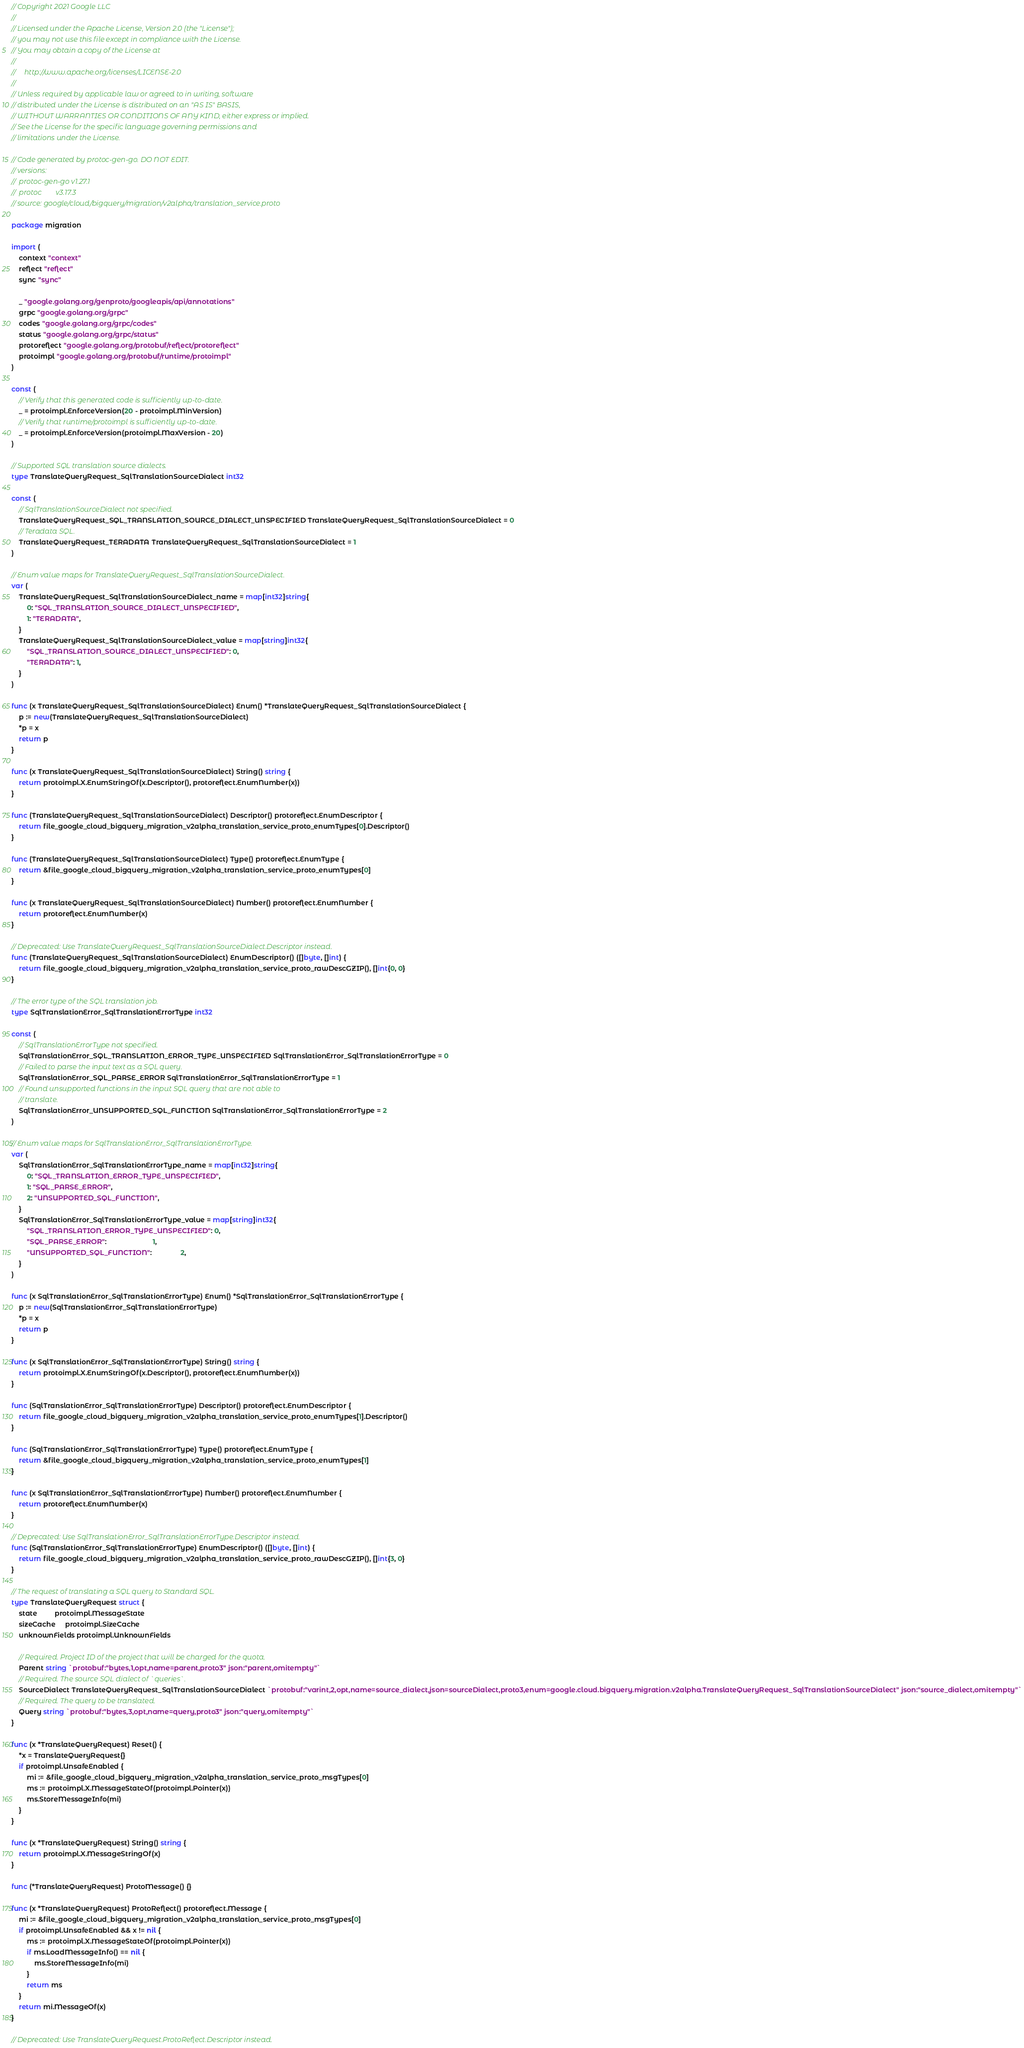Convert code to text. <code><loc_0><loc_0><loc_500><loc_500><_Go_>// Copyright 2021 Google LLC
//
// Licensed under the Apache License, Version 2.0 (the "License");
// you may not use this file except in compliance with the License.
// You may obtain a copy of the License at
//
//     http://www.apache.org/licenses/LICENSE-2.0
//
// Unless required by applicable law or agreed to in writing, software
// distributed under the License is distributed on an "AS IS" BASIS,
// WITHOUT WARRANTIES OR CONDITIONS OF ANY KIND, either express or implied.
// See the License for the specific language governing permissions and
// limitations under the License.

// Code generated by protoc-gen-go. DO NOT EDIT.
// versions:
// 	protoc-gen-go v1.27.1
// 	protoc        v3.17.3
// source: google/cloud/bigquery/migration/v2alpha/translation_service.proto

package migration

import (
	context "context"
	reflect "reflect"
	sync "sync"

	_ "google.golang.org/genproto/googleapis/api/annotations"
	grpc "google.golang.org/grpc"
	codes "google.golang.org/grpc/codes"
	status "google.golang.org/grpc/status"
	protoreflect "google.golang.org/protobuf/reflect/protoreflect"
	protoimpl "google.golang.org/protobuf/runtime/protoimpl"
)

const (
	// Verify that this generated code is sufficiently up-to-date.
	_ = protoimpl.EnforceVersion(20 - protoimpl.MinVersion)
	// Verify that runtime/protoimpl is sufficiently up-to-date.
	_ = protoimpl.EnforceVersion(protoimpl.MaxVersion - 20)
)

// Supported SQL translation source dialects.
type TranslateQueryRequest_SqlTranslationSourceDialect int32

const (
	// SqlTranslationSourceDialect not specified.
	TranslateQueryRequest_SQL_TRANSLATION_SOURCE_DIALECT_UNSPECIFIED TranslateQueryRequest_SqlTranslationSourceDialect = 0
	// Teradata SQL.
	TranslateQueryRequest_TERADATA TranslateQueryRequest_SqlTranslationSourceDialect = 1
)

// Enum value maps for TranslateQueryRequest_SqlTranslationSourceDialect.
var (
	TranslateQueryRequest_SqlTranslationSourceDialect_name = map[int32]string{
		0: "SQL_TRANSLATION_SOURCE_DIALECT_UNSPECIFIED",
		1: "TERADATA",
	}
	TranslateQueryRequest_SqlTranslationSourceDialect_value = map[string]int32{
		"SQL_TRANSLATION_SOURCE_DIALECT_UNSPECIFIED": 0,
		"TERADATA": 1,
	}
)

func (x TranslateQueryRequest_SqlTranslationSourceDialect) Enum() *TranslateQueryRequest_SqlTranslationSourceDialect {
	p := new(TranslateQueryRequest_SqlTranslationSourceDialect)
	*p = x
	return p
}

func (x TranslateQueryRequest_SqlTranslationSourceDialect) String() string {
	return protoimpl.X.EnumStringOf(x.Descriptor(), protoreflect.EnumNumber(x))
}

func (TranslateQueryRequest_SqlTranslationSourceDialect) Descriptor() protoreflect.EnumDescriptor {
	return file_google_cloud_bigquery_migration_v2alpha_translation_service_proto_enumTypes[0].Descriptor()
}

func (TranslateQueryRequest_SqlTranslationSourceDialect) Type() protoreflect.EnumType {
	return &file_google_cloud_bigquery_migration_v2alpha_translation_service_proto_enumTypes[0]
}

func (x TranslateQueryRequest_SqlTranslationSourceDialect) Number() protoreflect.EnumNumber {
	return protoreflect.EnumNumber(x)
}

// Deprecated: Use TranslateQueryRequest_SqlTranslationSourceDialect.Descriptor instead.
func (TranslateQueryRequest_SqlTranslationSourceDialect) EnumDescriptor() ([]byte, []int) {
	return file_google_cloud_bigquery_migration_v2alpha_translation_service_proto_rawDescGZIP(), []int{0, 0}
}

// The error type of the SQL translation job.
type SqlTranslationError_SqlTranslationErrorType int32

const (
	// SqlTranslationErrorType not specified.
	SqlTranslationError_SQL_TRANSLATION_ERROR_TYPE_UNSPECIFIED SqlTranslationError_SqlTranslationErrorType = 0
	// Failed to parse the input text as a SQL query.
	SqlTranslationError_SQL_PARSE_ERROR SqlTranslationError_SqlTranslationErrorType = 1
	// Found unsupported functions in the input SQL query that are not able to
	// translate.
	SqlTranslationError_UNSUPPORTED_SQL_FUNCTION SqlTranslationError_SqlTranslationErrorType = 2
)

// Enum value maps for SqlTranslationError_SqlTranslationErrorType.
var (
	SqlTranslationError_SqlTranslationErrorType_name = map[int32]string{
		0: "SQL_TRANSLATION_ERROR_TYPE_UNSPECIFIED",
		1: "SQL_PARSE_ERROR",
		2: "UNSUPPORTED_SQL_FUNCTION",
	}
	SqlTranslationError_SqlTranslationErrorType_value = map[string]int32{
		"SQL_TRANSLATION_ERROR_TYPE_UNSPECIFIED": 0,
		"SQL_PARSE_ERROR":                        1,
		"UNSUPPORTED_SQL_FUNCTION":               2,
	}
)

func (x SqlTranslationError_SqlTranslationErrorType) Enum() *SqlTranslationError_SqlTranslationErrorType {
	p := new(SqlTranslationError_SqlTranslationErrorType)
	*p = x
	return p
}

func (x SqlTranslationError_SqlTranslationErrorType) String() string {
	return protoimpl.X.EnumStringOf(x.Descriptor(), protoreflect.EnumNumber(x))
}

func (SqlTranslationError_SqlTranslationErrorType) Descriptor() protoreflect.EnumDescriptor {
	return file_google_cloud_bigquery_migration_v2alpha_translation_service_proto_enumTypes[1].Descriptor()
}

func (SqlTranslationError_SqlTranslationErrorType) Type() protoreflect.EnumType {
	return &file_google_cloud_bigquery_migration_v2alpha_translation_service_proto_enumTypes[1]
}

func (x SqlTranslationError_SqlTranslationErrorType) Number() protoreflect.EnumNumber {
	return protoreflect.EnumNumber(x)
}

// Deprecated: Use SqlTranslationError_SqlTranslationErrorType.Descriptor instead.
func (SqlTranslationError_SqlTranslationErrorType) EnumDescriptor() ([]byte, []int) {
	return file_google_cloud_bigquery_migration_v2alpha_translation_service_proto_rawDescGZIP(), []int{3, 0}
}

// The request of translating a SQL query to Standard SQL.
type TranslateQueryRequest struct {
	state         protoimpl.MessageState
	sizeCache     protoimpl.SizeCache
	unknownFields protoimpl.UnknownFields

	// Required. Project ID of the project that will be charged for the quota.
	Parent string `protobuf:"bytes,1,opt,name=parent,proto3" json:"parent,omitempty"`
	// Required. The source SQL dialect of `queries`.
	SourceDialect TranslateQueryRequest_SqlTranslationSourceDialect `protobuf:"varint,2,opt,name=source_dialect,json=sourceDialect,proto3,enum=google.cloud.bigquery.migration.v2alpha.TranslateQueryRequest_SqlTranslationSourceDialect" json:"source_dialect,omitempty"`
	// Required. The query to be translated.
	Query string `protobuf:"bytes,3,opt,name=query,proto3" json:"query,omitempty"`
}

func (x *TranslateQueryRequest) Reset() {
	*x = TranslateQueryRequest{}
	if protoimpl.UnsafeEnabled {
		mi := &file_google_cloud_bigquery_migration_v2alpha_translation_service_proto_msgTypes[0]
		ms := protoimpl.X.MessageStateOf(protoimpl.Pointer(x))
		ms.StoreMessageInfo(mi)
	}
}

func (x *TranslateQueryRequest) String() string {
	return protoimpl.X.MessageStringOf(x)
}

func (*TranslateQueryRequest) ProtoMessage() {}

func (x *TranslateQueryRequest) ProtoReflect() protoreflect.Message {
	mi := &file_google_cloud_bigquery_migration_v2alpha_translation_service_proto_msgTypes[0]
	if protoimpl.UnsafeEnabled && x != nil {
		ms := protoimpl.X.MessageStateOf(protoimpl.Pointer(x))
		if ms.LoadMessageInfo() == nil {
			ms.StoreMessageInfo(mi)
		}
		return ms
	}
	return mi.MessageOf(x)
}

// Deprecated: Use TranslateQueryRequest.ProtoReflect.Descriptor instead.</code> 